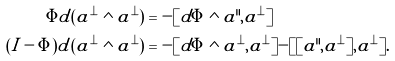Convert formula to latex. <formula><loc_0><loc_0><loc_500><loc_500>\Phi d ( a ^ { \bot } \wedge a ^ { \bot } ) & = - [ d \Phi \wedge a ^ { \| } , a ^ { \bot } ] \\ ( I - \Phi ) d ( a ^ { \bot } \wedge a ^ { \bot } ) & = - [ d \Phi \wedge a ^ { \bot } , a ^ { \bot } ] - [ [ a ^ { \| } , a ^ { \bot } ] , a ^ { \bot } ] .</formula> 